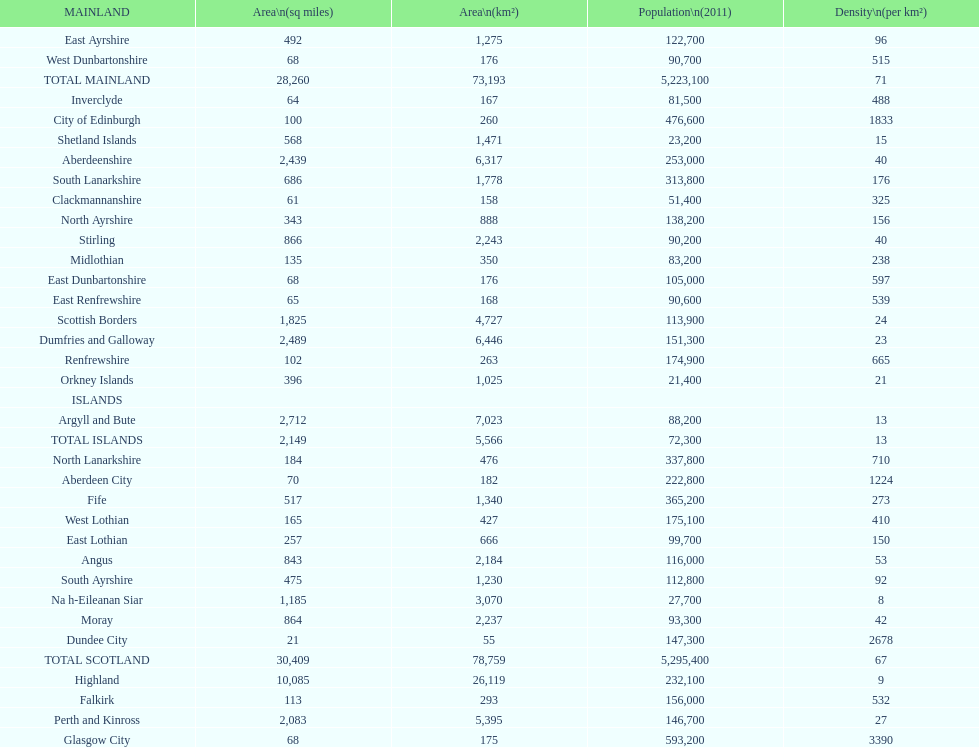What is the common population density in cities situated on the mainland? 71. 